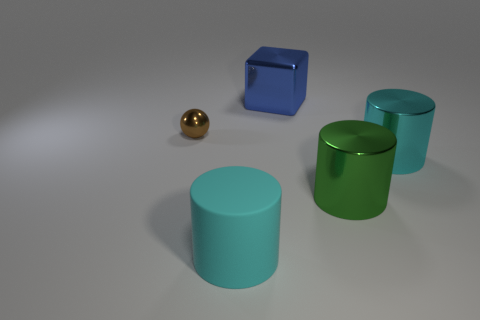Add 1 large blue things. How many objects exist? 6 Subtract all cyan cylinders. How many cylinders are left? 1 Subtract all large green metallic cylinders. How many cylinders are left? 2 Subtract 0 brown blocks. How many objects are left? 5 Subtract all cubes. How many objects are left? 4 Subtract all yellow cylinders. Subtract all purple cubes. How many cylinders are left? 3 Subtract all purple blocks. How many gray balls are left? 0 Subtract all matte cylinders. Subtract all big cyan metallic cylinders. How many objects are left? 3 Add 1 large cyan objects. How many large cyan objects are left? 3 Add 2 blue things. How many blue things exist? 3 